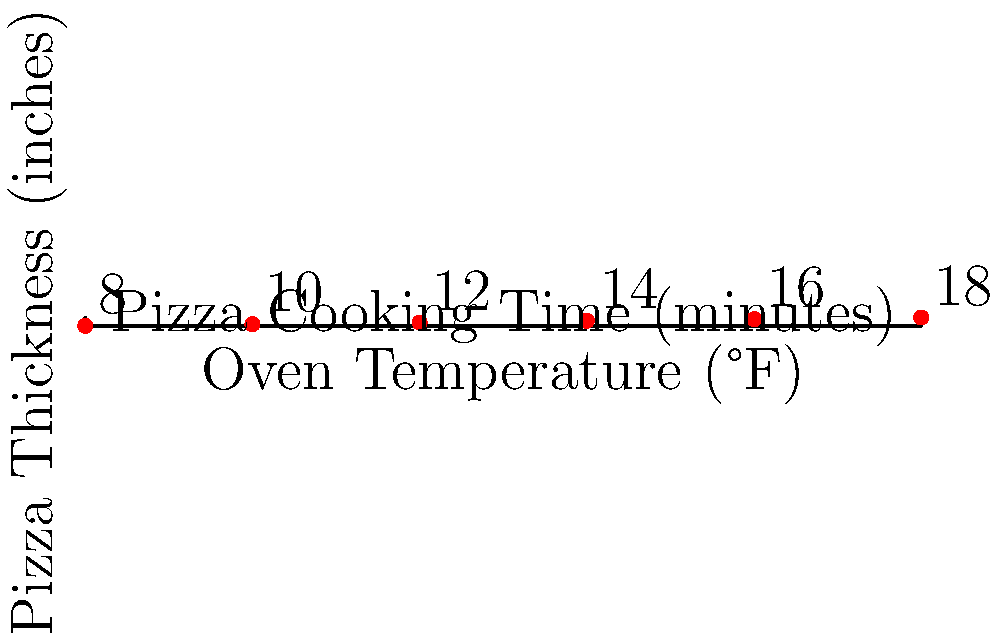Based on the scatter plot showing the relationship between oven temperature, pizza thickness, and cooking time, estimate the cooking time for a 1-inch thick pizza at 400°F. To estimate the cooking time for a 1-inch thick pizza at 400°F, we need to follow these steps:

1. Locate the point on the scatter plot where the oven temperature is 400°F and the pizza thickness is 1 inch.

2. Observe that this point falls exactly on one of the data points in the scatter plot.

3. Each data point on the plot is labeled with a number, which represents the cooking time in minutes.

4. The point corresponding to 400°F and 1 inch thickness is labeled with the number 12.

5. Therefore, the estimated cooking time for a 1-inch thick pizza at 400°F is 12 minutes.

This estimation is based on the data provided in the scatter plot, which likely represents the traditional cooking times used in the family-run pizzeria for various combinations of oven temperature and pizza thickness.
Answer: 12 minutes 